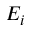Convert formula to latex. <formula><loc_0><loc_0><loc_500><loc_500>E _ { i }</formula> 